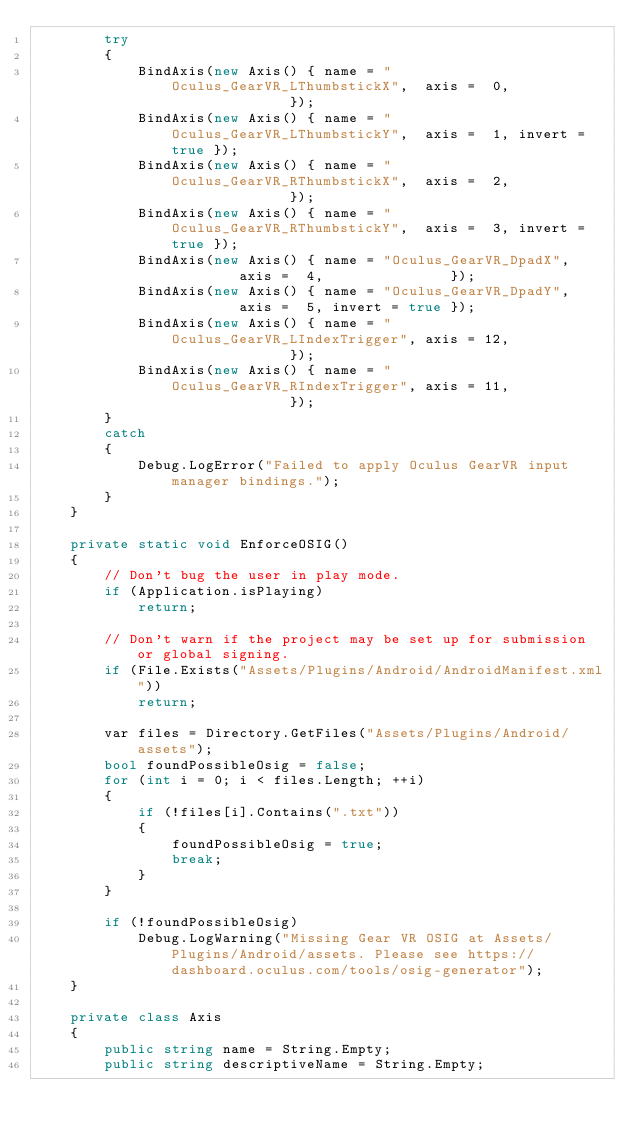<code> <loc_0><loc_0><loc_500><loc_500><_C#_>		try
		{
			BindAxis(new Axis() { name = "Oculus_GearVR_LThumbstickX",  axis =  0,               });
			BindAxis(new Axis() { name = "Oculus_GearVR_LThumbstickY",  axis =  1, invert = true });
			BindAxis(new Axis() { name = "Oculus_GearVR_RThumbstickX",  axis =  2,               });
			BindAxis(new Axis() { name = "Oculus_GearVR_RThumbstickY",  axis =  3, invert = true });
			BindAxis(new Axis() { name = "Oculus_GearVR_DpadX",         axis =  4,               });
			BindAxis(new Axis() { name = "Oculus_GearVR_DpadY",         axis =  5, invert = true });
			BindAxis(new Axis() { name = "Oculus_GearVR_LIndexTrigger", axis = 12,               });
			BindAxis(new Axis() { name = "Oculus_GearVR_RIndexTrigger", axis = 11,               });
		}
		catch
		{
			Debug.LogError("Failed to apply Oculus GearVR input manager bindings.");
		}
	}

	private static void EnforceOSIG()
	{
		// Don't bug the user in play mode.
		if (Application.isPlaying)
			return;
		
		// Don't warn if the project may be set up for submission or global signing.
		if (File.Exists("Assets/Plugins/Android/AndroidManifest.xml"))
			return;
		
		var files = Directory.GetFiles("Assets/Plugins/Android/assets");
		bool foundPossibleOsig = false;
		for (int i = 0; i < files.Length; ++i)
		{
			if (!files[i].Contains(".txt"))
			{
				foundPossibleOsig = true;
				break;
			}
		}

		if (!foundPossibleOsig)
			Debug.LogWarning("Missing Gear VR OSIG at Assets/Plugins/Android/assets. Please see https://dashboard.oculus.com/tools/osig-generator");
	}

	private class Axis
	{
		public string name = String.Empty;
		public string descriptiveName = String.Empty;</code> 